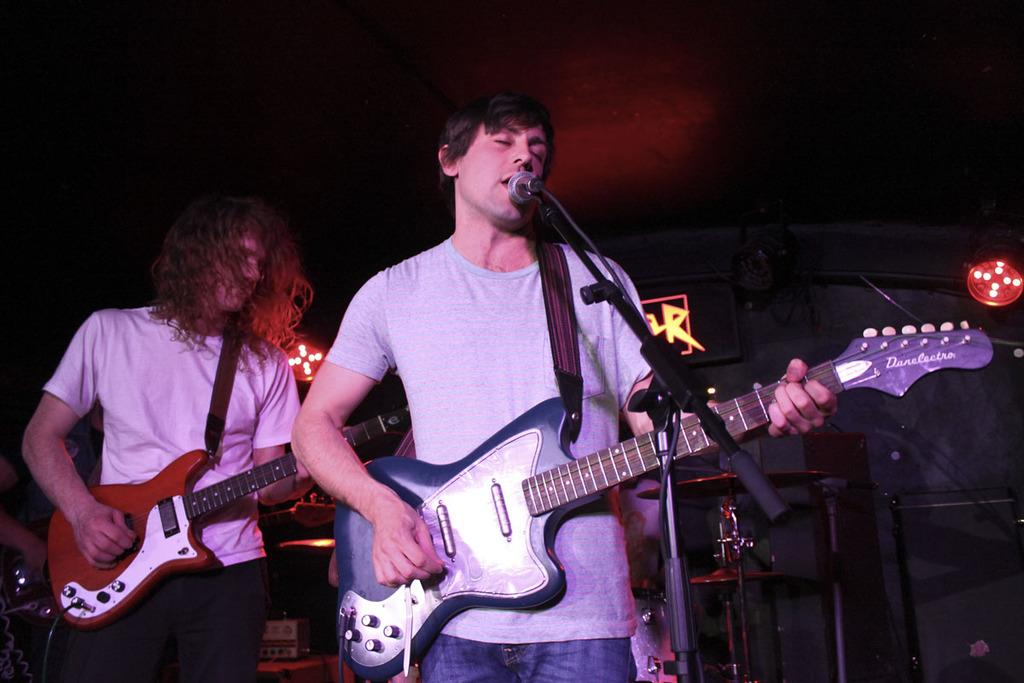What is the lighting condition in the image? The background of the image is dark. What are the two men in the image doing? They are playing guitars. What is the man in front of the microphone doing? He is singing. What other musical instrument can be seen in the image? There is a cymbal in the image. Can you describe the light visible in the image? Yes, there is a light visible in the image. What type of goat is standing next to the microphone in the image? There is no goat present in the image; it features two men playing guitars and a man singing in front of a microphone. What statement is being made by the man in front of the microphone in the image? The image does not provide any information about the lyrics or statement being made by the man in front of the microphone. 